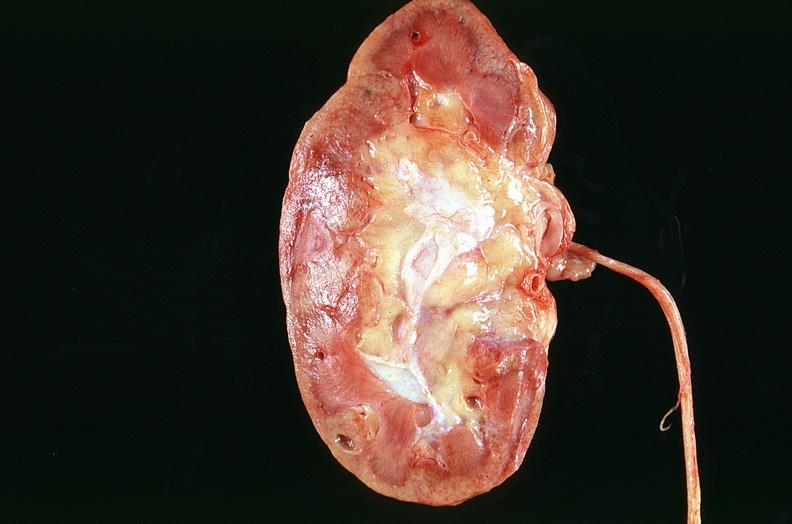where is this?
Answer the question using a single word or phrase. Urinary 